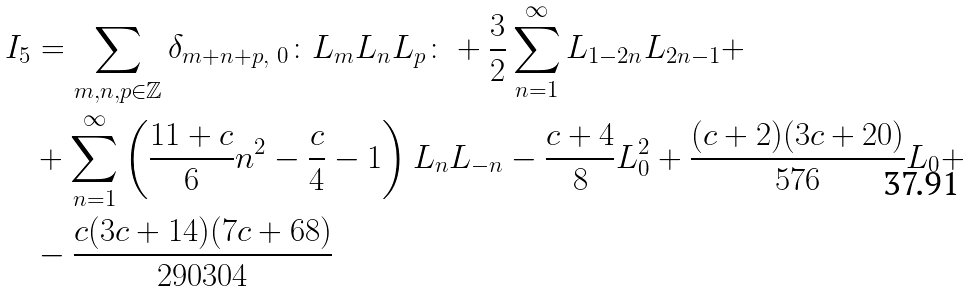<formula> <loc_0><loc_0><loc_500><loc_500>I _ { 5 } & = \sum _ { m , n , p \in \mathbb { Z } } \delta _ { m + n + p , \ 0 } \colon L _ { m } L _ { n } L _ { p } \colon + \frac { 3 } { 2 } \sum _ { n = 1 } ^ { \infty } L _ { 1 - 2 n } L _ { 2 n - 1 } + \\ & + \sum _ { n = 1 } ^ { \infty } \left ( \frac { 1 1 + c } { 6 } n ^ { 2 } - \frac { c } { 4 } - 1 \right ) L _ { n } L _ { - n } - \frac { c + 4 } { 8 } L _ { 0 } ^ { 2 } + \frac { ( c + 2 ) ( 3 c + 2 0 ) } { 5 7 6 } L _ { 0 } + \\ & - \frac { c ( 3 c + 1 4 ) ( 7 c + 6 8 ) } { 2 9 0 3 0 4 }</formula> 